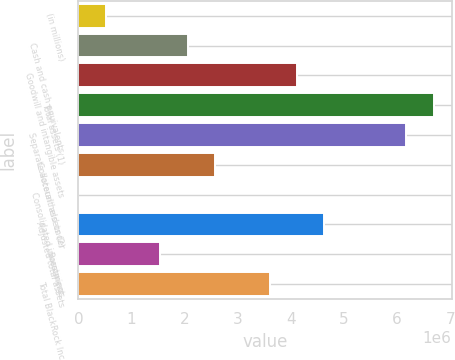Convert chart to OTSL. <chart><loc_0><loc_0><loc_500><loc_500><bar_chart><fcel>(in millions)<fcel>Cash and cash equivalents<fcel>Goodwill and intangible assets<fcel>Total assets (1)<fcel>Separate account assets (2)<fcel>Collateral held under<fcel>Consolidated investment<fcel>Adjusted total assets<fcel>Borrowings<fcel>Total BlackRock Inc<nl><fcel>515123<fcel>2.05937e+06<fcel>4.11836e+06<fcel>6.6921e+06<fcel>6.17735e+06<fcel>2.57411e+06<fcel>375<fcel>4.6331e+06<fcel>1.54462e+06<fcel>3.60361e+06<nl></chart> 